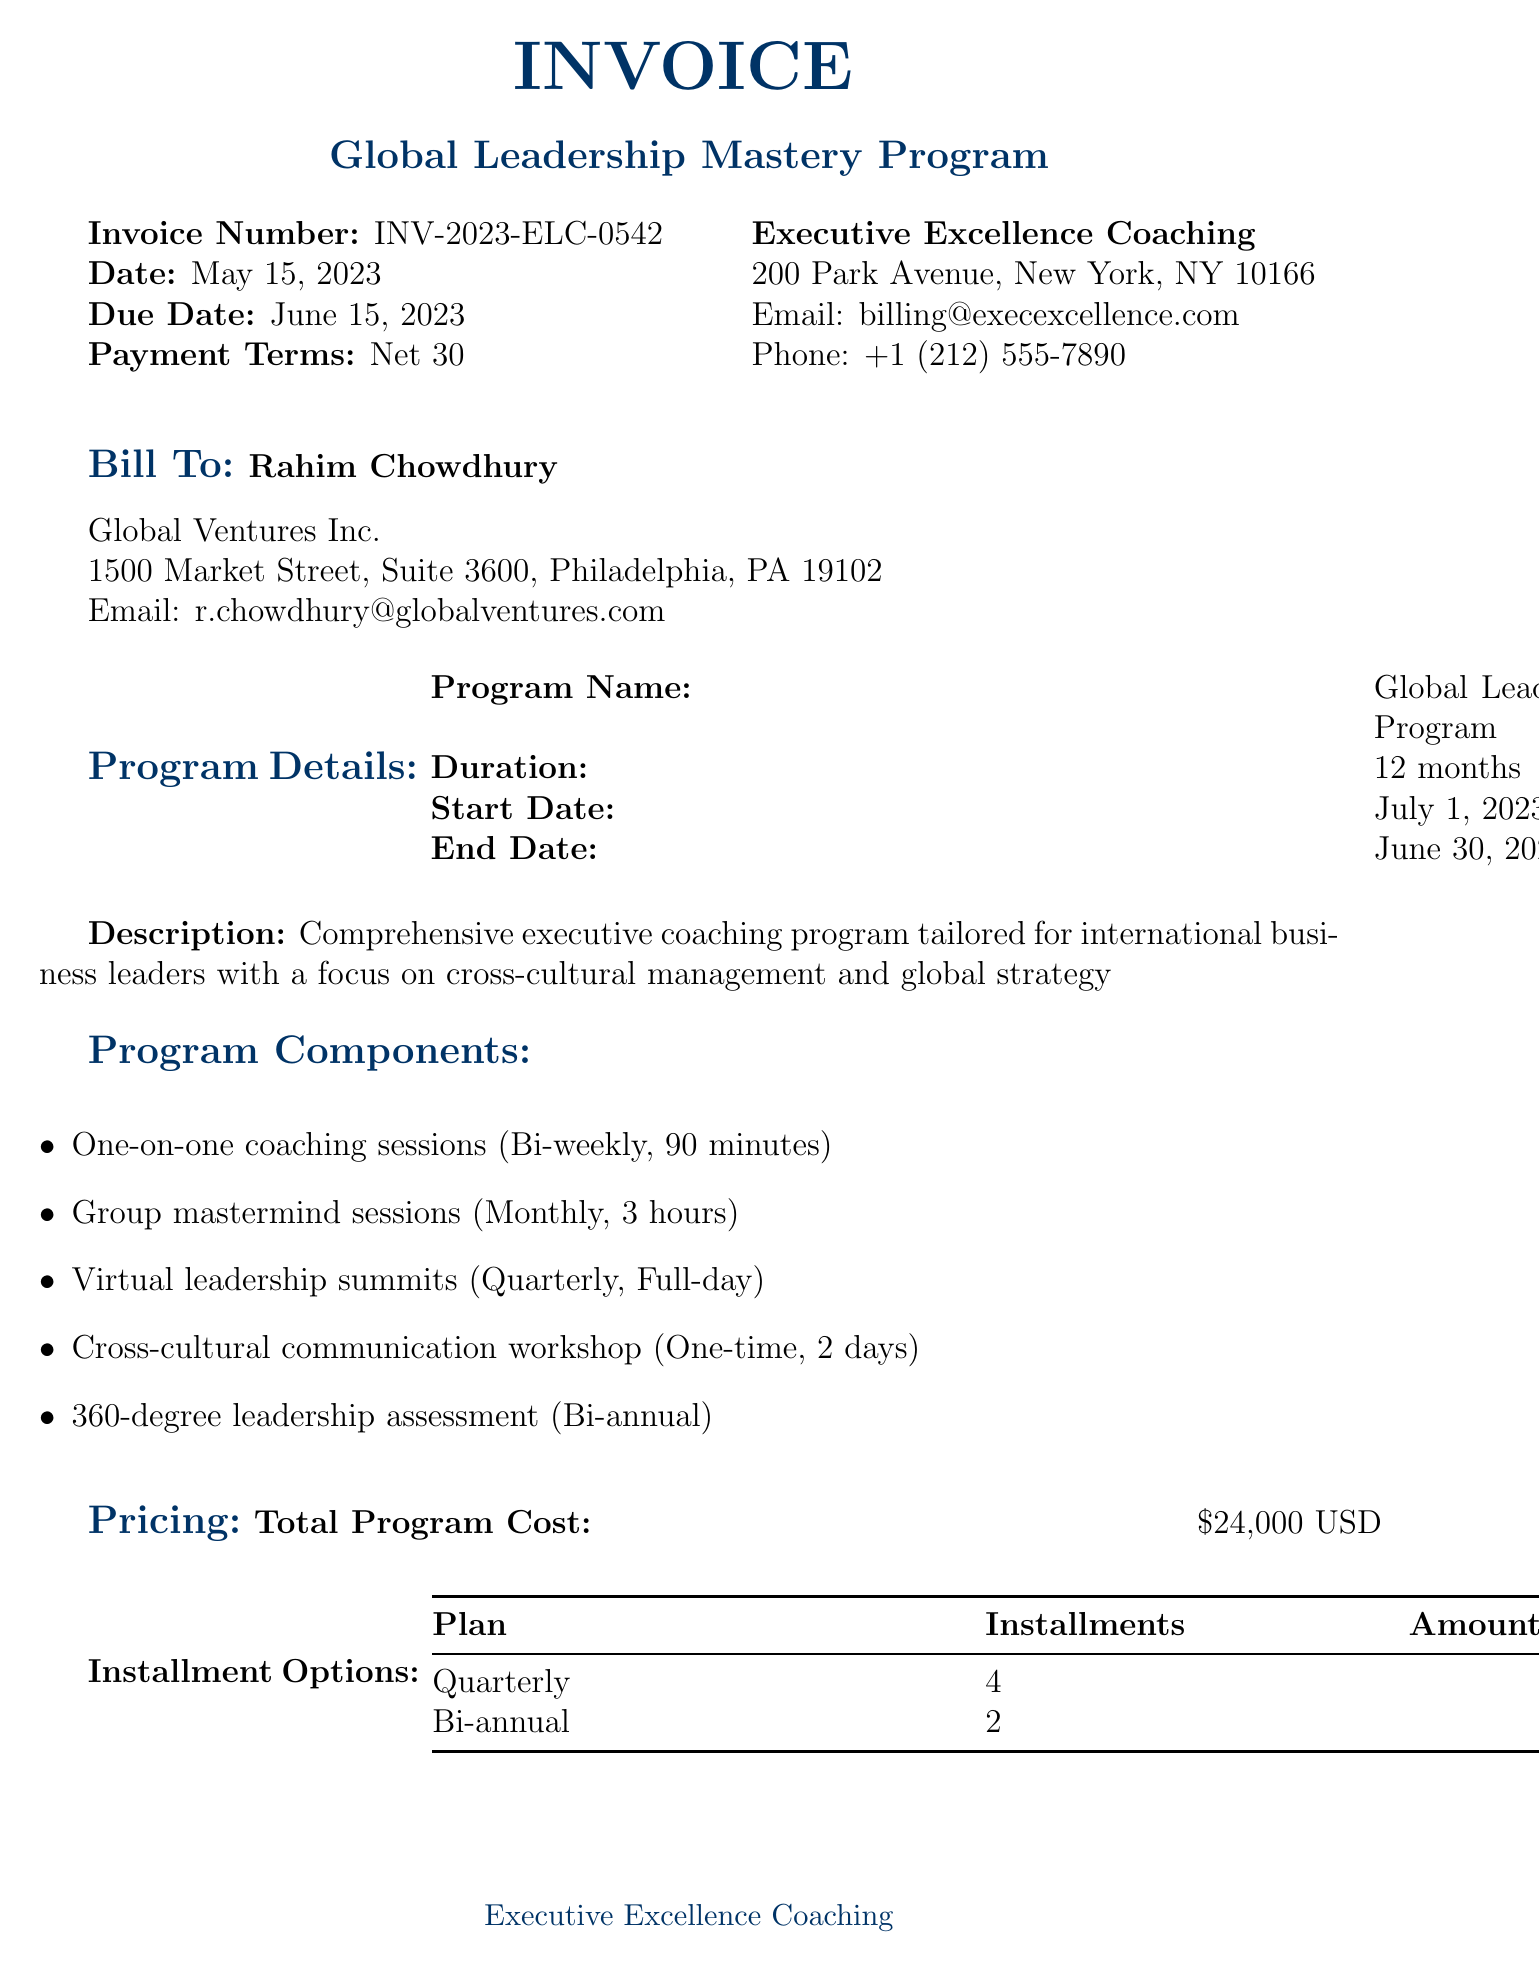What is the invoice number? The invoice number is explicitly stated in the document as a unique identifier for this invoice.
Answer: INV-2023-ELC-0542 What is the total amount due? The total amount due is mentioned under the pricing section of the invoice.
Answer: $24,000 USD Who is the client? The client’s name is specified at the beginning of the document, identifying the individual being billed.
Answer: Rahim Chowdhury What is the start date of the program? The start date of the program is specified in the program details section of the document.
Answer: July 1, 2023 How many installments are there in the quarterly plan? The quarterly plan is outlined in the installment options, indicating the number of payments.
Answer: 4 What type of workshop is included in the program components? The program components section includes various events, identifying the types of activities included in the program.
Answer: Cross-cultural communication workshop Which bank is used for payments? The payment instructions specify the bank information where payments should be directed.
Answer: Chase Bank What is the frequency of one-on-one coaching sessions? The frequency of the coaching sessions is specified in the program components, detailing how often they occur.
Answer: Bi-weekly What is the end date of the program? The end date is explicitly mentioned in the program details section, marking the conclusion of the program.
Answer: June 30, 2024 